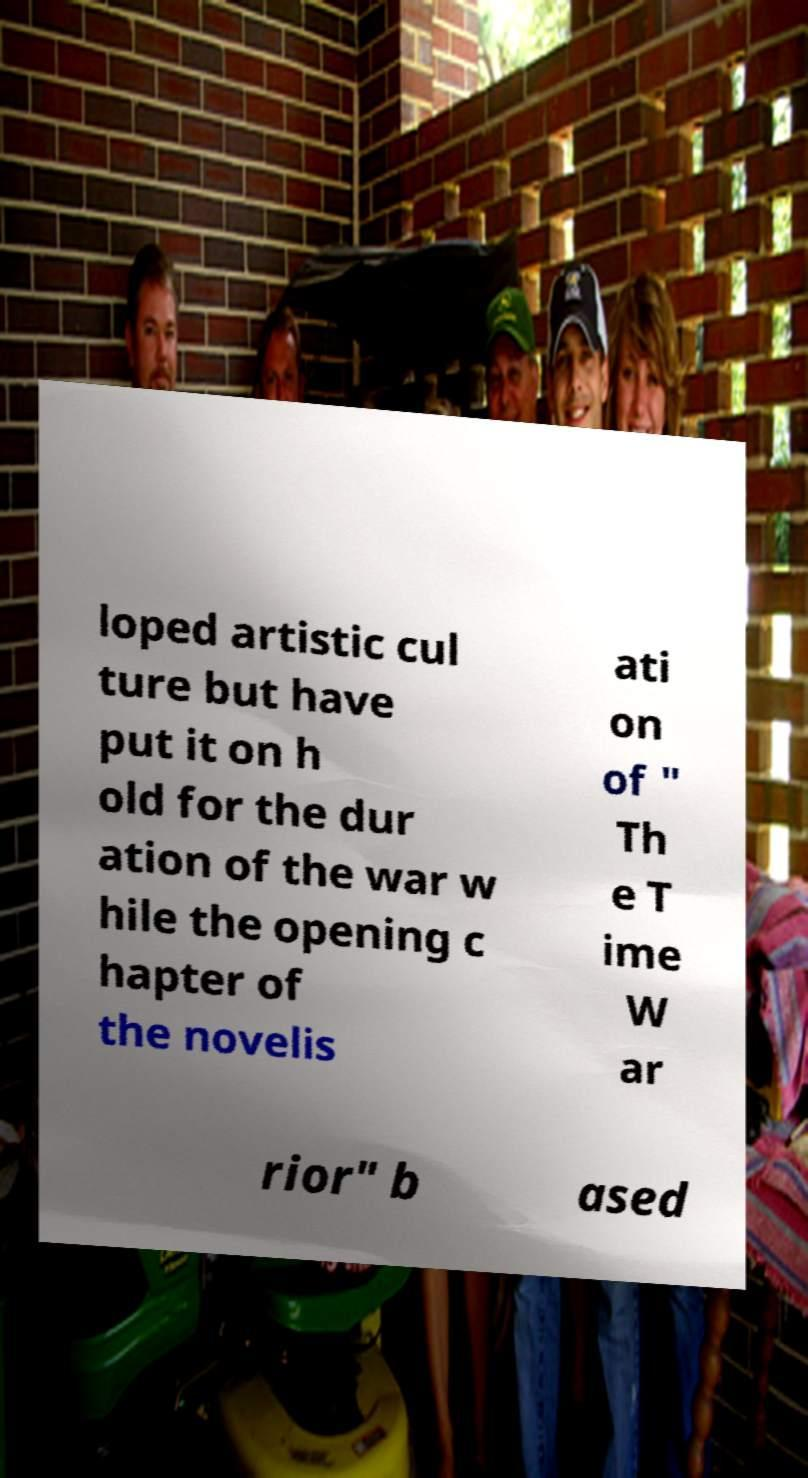Please read and relay the text visible in this image. What does it say? loped artistic cul ture but have put it on h old for the dur ation of the war w hile the opening c hapter of the novelis ati on of " Th e T ime W ar rior" b ased 